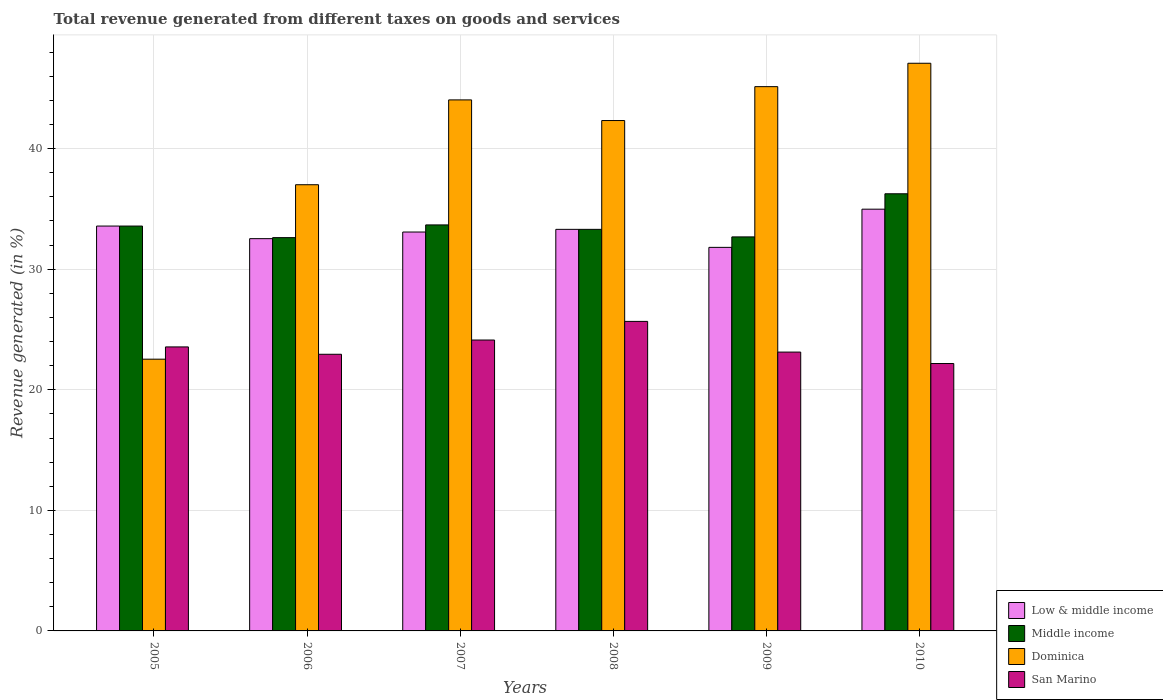How many different coloured bars are there?
Your answer should be compact. 4. Are the number of bars per tick equal to the number of legend labels?
Provide a short and direct response. Yes. What is the total revenue generated in Middle income in 2007?
Your response must be concise. 33.68. Across all years, what is the maximum total revenue generated in Dominica?
Make the answer very short. 47.08. Across all years, what is the minimum total revenue generated in Middle income?
Ensure brevity in your answer.  32.62. In which year was the total revenue generated in Middle income minimum?
Offer a terse response. 2006. What is the total total revenue generated in Low & middle income in the graph?
Your answer should be compact. 199.3. What is the difference between the total revenue generated in San Marino in 2006 and that in 2008?
Your response must be concise. -2.73. What is the difference between the total revenue generated in San Marino in 2008 and the total revenue generated in Dominica in 2005?
Your answer should be very brief. 3.13. What is the average total revenue generated in Dominica per year?
Your answer should be compact. 39.69. In the year 2005, what is the difference between the total revenue generated in Middle income and total revenue generated in San Marino?
Make the answer very short. 10.02. What is the ratio of the total revenue generated in San Marino in 2006 to that in 2009?
Your response must be concise. 0.99. Is the total revenue generated in Low & middle income in 2009 less than that in 2010?
Offer a very short reply. Yes. Is the difference between the total revenue generated in Middle income in 2005 and 2009 greater than the difference between the total revenue generated in San Marino in 2005 and 2009?
Provide a short and direct response. Yes. What is the difference between the highest and the second highest total revenue generated in Middle income?
Your answer should be compact. 2.58. What is the difference between the highest and the lowest total revenue generated in Middle income?
Give a very brief answer. 3.64. What does the 4th bar from the right in 2006 represents?
Make the answer very short. Low & middle income. Is it the case that in every year, the sum of the total revenue generated in Dominica and total revenue generated in Middle income is greater than the total revenue generated in San Marino?
Your answer should be very brief. Yes. How many bars are there?
Your answer should be very brief. 24. Are all the bars in the graph horizontal?
Keep it short and to the point. No. What is the difference between two consecutive major ticks on the Y-axis?
Offer a very short reply. 10. Does the graph contain any zero values?
Offer a very short reply. No. Where does the legend appear in the graph?
Keep it short and to the point. Bottom right. How are the legend labels stacked?
Ensure brevity in your answer.  Vertical. What is the title of the graph?
Keep it short and to the point. Total revenue generated from different taxes on goods and services. Does "Oman" appear as one of the legend labels in the graph?
Give a very brief answer. No. What is the label or title of the X-axis?
Offer a terse response. Years. What is the label or title of the Y-axis?
Provide a succinct answer. Revenue generated (in %). What is the Revenue generated (in %) of Low & middle income in 2005?
Make the answer very short. 33.58. What is the Revenue generated (in %) of Middle income in 2005?
Give a very brief answer. 33.58. What is the Revenue generated (in %) in Dominica in 2005?
Ensure brevity in your answer.  22.54. What is the Revenue generated (in %) in San Marino in 2005?
Your answer should be very brief. 23.56. What is the Revenue generated (in %) of Low & middle income in 2006?
Offer a very short reply. 32.54. What is the Revenue generated (in %) in Middle income in 2006?
Your answer should be very brief. 32.62. What is the Revenue generated (in %) of Dominica in 2006?
Your answer should be compact. 37.01. What is the Revenue generated (in %) of San Marino in 2006?
Ensure brevity in your answer.  22.95. What is the Revenue generated (in %) of Low & middle income in 2007?
Make the answer very short. 33.08. What is the Revenue generated (in %) of Middle income in 2007?
Offer a terse response. 33.68. What is the Revenue generated (in %) in Dominica in 2007?
Offer a terse response. 44.04. What is the Revenue generated (in %) in San Marino in 2007?
Give a very brief answer. 24.13. What is the Revenue generated (in %) of Low & middle income in 2008?
Keep it short and to the point. 33.31. What is the Revenue generated (in %) of Middle income in 2008?
Your answer should be very brief. 33.31. What is the Revenue generated (in %) of Dominica in 2008?
Make the answer very short. 42.33. What is the Revenue generated (in %) of San Marino in 2008?
Keep it short and to the point. 25.67. What is the Revenue generated (in %) in Low & middle income in 2009?
Your answer should be very brief. 31.81. What is the Revenue generated (in %) in Middle income in 2009?
Make the answer very short. 32.68. What is the Revenue generated (in %) of Dominica in 2009?
Provide a short and direct response. 45.14. What is the Revenue generated (in %) of San Marino in 2009?
Make the answer very short. 23.13. What is the Revenue generated (in %) in Low & middle income in 2010?
Provide a succinct answer. 34.98. What is the Revenue generated (in %) of Middle income in 2010?
Ensure brevity in your answer.  36.26. What is the Revenue generated (in %) of Dominica in 2010?
Give a very brief answer. 47.08. What is the Revenue generated (in %) of San Marino in 2010?
Your response must be concise. 22.18. Across all years, what is the maximum Revenue generated (in %) in Low & middle income?
Offer a very short reply. 34.98. Across all years, what is the maximum Revenue generated (in %) in Middle income?
Offer a terse response. 36.26. Across all years, what is the maximum Revenue generated (in %) of Dominica?
Make the answer very short. 47.08. Across all years, what is the maximum Revenue generated (in %) of San Marino?
Provide a succinct answer. 25.67. Across all years, what is the minimum Revenue generated (in %) of Low & middle income?
Offer a very short reply. 31.81. Across all years, what is the minimum Revenue generated (in %) of Middle income?
Ensure brevity in your answer.  32.62. Across all years, what is the minimum Revenue generated (in %) of Dominica?
Your response must be concise. 22.54. Across all years, what is the minimum Revenue generated (in %) in San Marino?
Offer a terse response. 22.18. What is the total Revenue generated (in %) in Low & middle income in the graph?
Keep it short and to the point. 199.3. What is the total Revenue generated (in %) in Middle income in the graph?
Keep it short and to the point. 202.12. What is the total Revenue generated (in %) in Dominica in the graph?
Ensure brevity in your answer.  238.15. What is the total Revenue generated (in %) of San Marino in the graph?
Provide a succinct answer. 141.61. What is the difference between the Revenue generated (in %) in Low & middle income in 2005 and that in 2006?
Provide a succinct answer. 1.04. What is the difference between the Revenue generated (in %) of Middle income in 2005 and that in 2006?
Offer a very short reply. 0.96. What is the difference between the Revenue generated (in %) of Dominica in 2005 and that in 2006?
Keep it short and to the point. -14.47. What is the difference between the Revenue generated (in %) in San Marino in 2005 and that in 2006?
Offer a very short reply. 0.61. What is the difference between the Revenue generated (in %) of Low & middle income in 2005 and that in 2007?
Ensure brevity in your answer.  0.5. What is the difference between the Revenue generated (in %) of Middle income in 2005 and that in 2007?
Keep it short and to the point. -0.1. What is the difference between the Revenue generated (in %) of Dominica in 2005 and that in 2007?
Offer a terse response. -21.51. What is the difference between the Revenue generated (in %) in San Marino in 2005 and that in 2007?
Your response must be concise. -0.57. What is the difference between the Revenue generated (in %) of Low & middle income in 2005 and that in 2008?
Your response must be concise. 0.27. What is the difference between the Revenue generated (in %) in Middle income in 2005 and that in 2008?
Ensure brevity in your answer.  0.27. What is the difference between the Revenue generated (in %) in Dominica in 2005 and that in 2008?
Make the answer very short. -19.79. What is the difference between the Revenue generated (in %) of San Marino in 2005 and that in 2008?
Give a very brief answer. -2.12. What is the difference between the Revenue generated (in %) in Low & middle income in 2005 and that in 2009?
Provide a short and direct response. 1.77. What is the difference between the Revenue generated (in %) of Middle income in 2005 and that in 2009?
Keep it short and to the point. 0.9. What is the difference between the Revenue generated (in %) in Dominica in 2005 and that in 2009?
Provide a short and direct response. -22.6. What is the difference between the Revenue generated (in %) in San Marino in 2005 and that in 2009?
Your answer should be compact. 0.43. What is the difference between the Revenue generated (in %) in Low & middle income in 2005 and that in 2010?
Give a very brief answer. -1.4. What is the difference between the Revenue generated (in %) in Middle income in 2005 and that in 2010?
Give a very brief answer. -2.68. What is the difference between the Revenue generated (in %) of Dominica in 2005 and that in 2010?
Offer a terse response. -24.54. What is the difference between the Revenue generated (in %) in San Marino in 2005 and that in 2010?
Provide a succinct answer. 1.38. What is the difference between the Revenue generated (in %) of Low & middle income in 2006 and that in 2007?
Keep it short and to the point. -0.55. What is the difference between the Revenue generated (in %) of Middle income in 2006 and that in 2007?
Provide a short and direct response. -1.06. What is the difference between the Revenue generated (in %) of Dominica in 2006 and that in 2007?
Give a very brief answer. -7.04. What is the difference between the Revenue generated (in %) of San Marino in 2006 and that in 2007?
Offer a terse response. -1.18. What is the difference between the Revenue generated (in %) in Low & middle income in 2006 and that in 2008?
Ensure brevity in your answer.  -0.77. What is the difference between the Revenue generated (in %) in Middle income in 2006 and that in 2008?
Provide a short and direct response. -0.69. What is the difference between the Revenue generated (in %) of Dominica in 2006 and that in 2008?
Provide a short and direct response. -5.32. What is the difference between the Revenue generated (in %) of San Marino in 2006 and that in 2008?
Your answer should be compact. -2.73. What is the difference between the Revenue generated (in %) of Low & middle income in 2006 and that in 2009?
Your answer should be very brief. 0.72. What is the difference between the Revenue generated (in %) of Middle income in 2006 and that in 2009?
Ensure brevity in your answer.  -0.06. What is the difference between the Revenue generated (in %) in Dominica in 2006 and that in 2009?
Provide a succinct answer. -8.14. What is the difference between the Revenue generated (in %) of San Marino in 2006 and that in 2009?
Your answer should be compact. -0.18. What is the difference between the Revenue generated (in %) in Low & middle income in 2006 and that in 2010?
Give a very brief answer. -2.44. What is the difference between the Revenue generated (in %) in Middle income in 2006 and that in 2010?
Ensure brevity in your answer.  -3.64. What is the difference between the Revenue generated (in %) of Dominica in 2006 and that in 2010?
Make the answer very short. -10.07. What is the difference between the Revenue generated (in %) of San Marino in 2006 and that in 2010?
Ensure brevity in your answer.  0.77. What is the difference between the Revenue generated (in %) of Low & middle income in 2007 and that in 2008?
Ensure brevity in your answer.  -0.22. What is the difference between the Revenue generated (in %) in Middle income in 2007 and that in 2008?
Your answer should be very brief. 0.37. What is the difference between the Revenue generated (in %) in Dominica in 2007 and that in 2008?
Provide a short and direct response. 1.71. What is the difference between the Revenue generated (in %) in San Marino in 2007 and that in 2008?
Your answer should be compact. -1.55. What is the difference between the Revenue generated (in %) in Low & middle income in 2007 and that in 2009?
Make the answer very short. 1.27. What is the difference between the Revenue generated (in %) of Dominica in 2007 and that in 2009?
Provide a succinct answer. -1.1. What is the difference between the Revenue generated (in %) of Low & middle income in 2007 and that in 2010?
Your answer should be compact. -1.89. What is the difference between the Revenue generated (in %) of Middle income in 2007 and that in 2010?
Your answer should be compact. -2.58. What is the difference between the Revenue generated (in %) of Dominica in 2007 and that in 2010?
Offer a terse response. -3.04. What is the difference between the Revenue generated (in %) in San Marino in 2007 and that in 2010?
Provide a short and direct response. 1.95. What is the difference between the Revenue generated (in %) in Low & middle income in 2008 and that in 2009?
Provide a succinct answer. 1.49. What is the difference between the Revenue generated (in %) in Middle income in 2008 and that in 2009?
Offer a terse response. 0.63. What is the difference between the Revenue generated (in %) in Dominica in 2008 and that in 2009?
Keep it short and to the point. -2.81. What is the difference between the Revenue generated (in %) in San Marino in 2008 and that in 2009?
Give a very brief answer. 2.55. What is the difference between the Revenue generated (in %) in Low & middle income in 2008 and that in 2010?
Give a very brief answer. -1.67. What is the difference between the Revenue generated (in %) of Middle income in 2008 and that in 2010?
Provide a short and direct response. -2.95. What is the difference between the Revenue generated (in %) in Dominica in 2008 and that in 2010?
Make the answer very short. -4.75. What is the difference between the Revenue generated (in %) in San Marino in 2008 and that in 2010?
Make the answer very short. 3.49. What is the difference between the Revenue generated (in %) in Low & middle income in 2009 and that in 2010?
Offer a terse response. -3.17. What is the difference between the Revenue generated (in %) of Middle income in 2009 and that in 2010?
Provide a succinct answer. -3.58. What is the difference between the Revenue generated (in %) of Dominica in 2009 and that in 2010?
Give a very brief answer. -1.94. What is the difference between the Revenue generated (in %) of San Marino in 2009 and that in 2010?
Provide a succinct answer. 0.95. What is the difference between the Revenue generated (in %) of Low & middle income in 2005 and the Revenue generated (in %) of Middle income in 2006?
Your response must be concise. 0.96. What is the difference between the Revenue generated (in %) in Low & middle income in 2005 and the Revenue generated (in %) in Dominica in 2006?
Provide a short and direct response. -3.43. What is the difference between the Revenue generated (in %) of Low & middle income in 2005 and the Revenue generated (in %) of San Marino in 2006?
Offer a very short reply. 10.63. What is the difference between the Revenue generated (in %) in Middle income in 2005 and the Revenue generated (in %) in Dominica in 2006?
Offer a terse response. -3.43. What is the difference between the Revenue generated (in %) of Middle income in 2005 and the Revenue generated (in %) of San Marino in 2006?
Ensure brevity in your answer.  10.63. What is the difference between the Revenue generated (in %) of Dominica in 2005 and the Revenue generated (in %) of San Marino in 2006?
Offer a very short reply. -0.41. What is the difference between the Revenue generated (in %) of Low & middle income in 2005 and the Revenue generated (in %) of Middle income in 2007?
Give a very brief answer. -0.1. What is the difference between the Revenue generated (in %) in Low & middle income in 2005 and the Revenue generated (in %) in Dominica in 2007?
Offer a very short reply. -10.46. What is the difference between the Revenue generated (in %) of Low & middle income in 2005 and the Revenue generated (in %) of San Marino in 2007?
Give a very brief answer. 9.45. What is the difference between the Revenue generated (in %) of Middle income in 2005 and the Revenue generated (in %) of Dominica in 2007?
Ensure brevity in your answer.  -10.46. What is the difference between the Revenue generated (in %) of Middle income in 2005 and the Revenue generated (in %) of San Marino in 2007?
Provide a short and direct response. 9.45. What is the difference between the Revenue generated (in %) in Dominica in 2005 and the Revenue generated (in %) in San Marino in 2007?
Ensure brevity in your answer.  -1.59. What is the difference between the Revenue generated (in %) in Low & middle income in 2005 and the Revenue generated (in %) in Middle income in 2008?
Your response must be concise. 0.27. What is the difference between the Revenue generated (in %) in Low & middle income in 2005 and the Revenue generated (in %) in Dominica in 2008?
Your response must be concise. -8.75. What is the difference between the Revenue generated (in %) of Low & middle income in 2005 and the Revenue generated (in %) of San Marino in 2008?
Your response must be concise. 7.91. What is the difference between the Revenue generated (in %) of Middle income in 2005 and the Revenue generated (in %) of Dominica in 2008?
Offer a terse response. -8.75. What is the difference between the Revenue generated (in %) of Middle income in 2005 and the Revenue generated (in %) of San Marino in 2008?
Your answer should be compact. 7.91. What is the difference between the Revenue generated (in %) in Dominica in 2005 and the Revenue generated (in %) in San Marino in 2008?
Your answer should be compact. -3.13. What is the difference between the Revenue generated (in %) in Low & middle income in 2005 and the Revenue generated (in %) in Middle income in 2009?
Keep it short and to the point. 0.9. What is the difference between the Revenue generated (in %) in Low & middle income in 2005 and the Revenue generated (in %) in Dominica in 2009?
Make the answer very short. -11.56. What is the difference between the Revenue generated (in %) of Low & middle income in 2005 and the Revenue generated (in %) of San Marino in 2009?
Provide a short and direct response. 10.45. What is the difference between the Revenue generated (in %) of Middle income in 2005 and the Revenue generated (in %) of Dominica in 2009?
Your response must be concise. -11.56. What is the difference between the Revenue generated (in %) of Middle income in 2005 and the Revenue generated (in %) of San Marino in 2009?
Keep it short and to the point. 10.45. What is the difference between the Revenue generated (in %) in Dominica in 2005 and the Revenue generated (in %) in San Marino in 2009?
Your answer should be compact. -0.59. What is the difference between the Revenue generated (in %) of Low & middle income in 2005 and the Revenue generated (in %) of Middle income in 2010?
Provide a succinct answer. -2.68. What is the difference between the Revenue generated (in %) in Low & middle income in 2005 and the Revenue generated (in %) in Dominica in 2010?
Offer a very short reply. -13.5. What is the difference between the Revenue generated (in %) in Low & middle income in 2005 and the Revenue generated (in %) in San Marino in 2010?
Provide a succinct answer. 11.4. What is the difference between the Revenue generated (in %) in Middle income in 2005 and the Revenue generated (in %) in Dominica in 2010?
Give a very brief answer. -13.5. What is the difference between the Revenue generated (in %) of Middle income in 2005 and the Revenue generated (in %) of San Marino in 2010?
Offer a very short reply. 11.4. What is the difference between the Revenue generated (in %) of Dominica in 2005 and the Revenue generated (in %) of San Marino in 2010?
Offer a very short reply. 0.36. What is the difference between the Revenue generated (in %) in Low & middle income in 2006 and the Revenue generated (in %) in Middle income in 2007?
Keep it short and to the point. -1.14. What is the difference between the Revenue generated (in %) in Low & middle income in 2006 and the Revenue generated (in %) in Dominica in 2007?
Provide a short and direct response. -11.51. What is the difference between the Revenue generated (in %) in Low & middle income in 2006 and the Revenue generated (in %) in San Marino in 2007?
Your answer should be compact. 8.41. What is the difference between the Revenue generated (in %) of Middle income in 2006 and the Revenue generated (in %) of Dominica in 2007?
Offer a terse response. -11.42. What is the difference between the Revenue generated (in %) in Middle income in 2006 and the Revenue generated (in %) in San Marino in 2007?
Give a very brief answer. 8.49. What is the difference between the Revenue generated (in %) of Dominica in 2006 and the Revenue generated (in %) of San Marino in 2007?
Offer a very short reply. 12.88. What is the difference between the Revenue generated (in %) of Low & middle income in 2006 and the Revenue generated (in %) of Middle income in 2008?
Your answer should be compact. -0.77. What is the difference between the Revenue generated (in %) of Low & middle income in 2006 and the Revenue generated (in %) of Dominica in 2008?
Your answer should be very brief. -9.8. What is the difference between the Revenue generated (in %) of Low & middle income in 2006 and the Revenue generated (in %) of San Marino in 2008?
Offer a very short reply. 6.86. What is the difference between the Revenue generated (in %) in Middle income in 2006 and the Revenue generated (in %) in Dominica in 2008?
Your answer should be very brief. -9.71. What is the difference between the Revenue generated (in %) of Middle income in 2006 and the Revenue generated (in %) of San Marino in 2008?
Ensure brevity in your answer.  6.95. What is the difference between the Revenue generated (in %) of Dominica in 2006 and the Revenue generated (in %) of San Marino in 2008?
Ensure brevity in your answer.  11.34. What is the difference between the Revenue generated (in %) of Low & middle income in 2006 and the Revenue generated (in %) of Middle income in 2009?
Make the answer very short. -0.15. What is the difference between the Revenue generated (in %) of Low & middle income in 2006 and the Revenue generated (in %) of Dominica in 2009?
Offer a terse response. -12.61. What is the difference between the Revenue generated (in %) in Low & middle income in 2006 and the Revenue generated (in %) in San Marino in 2009?
Make the answer very short. 9.41. What is the difference between the Revenue generated (in %) of Middle income in 2006 and the Revenue generated (in %) of Dominica in 2009?
Give a very brief answer. -12.52. What is the difference between the Revenue generated (in %) in Middle income in 2006 and the Revenue generated (in %) in San Marino in 2009?
Ensure brevity in your answer.  9.49. What is the difference between the Revenue generated (in %) of Dominica in 2006 and the Revenue generated (in %) of San Marino in 2009?
Make the answer very short. 13.88. What is the difference between the Revenue generated (in %) of Low & middle income in 2006 and the Revenue generated (in %) of Middle income in 2010?
Give a very brief answer. -3.72. What is the difference between the Revenue generated (in %) in Low & middle income in 2006 and the Revenue generated (in %) in Dominica in 2010?
Provide a succinct answer. -14.55. What is the difference between the Revenue generated (in %) of Low & middle income in 2006 and the Revenue generated (in %) of San Marino in 2010?
Your answer should be compact. 10.36. What is the difference between the Revenue generated (in %) of Middle income in 2006 and the Revenue generated (in %) of Dominica in 2010?
Provide a short and direct response. -14.46. What is the difference between the Revenue generated (in %) of Middle income in 2006 and the Revenue generated (in %) of San Marino in 2010?
Offer a terse response. 10.44. What is the difference between the Revenue generated (in %) in Dominica in 2006 and the Revenue generated (in %) in San Marino in 2010?
Give a very brief answer. 14.83. What is the difference between the Revenue generated (in %) of Low & middle income in 2007 and the Revenue generated (in %) of Middle income in 2008?
Offer a terse response. -0.22. What is the difference between the Revenue generated (in %) in Low & middle income in 2007 and the Revenue generated (in %) in Dominica in 2008?
Your answer should be compact. -9.25. What is the difference between the Revenue generated (in %) of Low & middle income in 2007 and the Revenue generated (in %) of San Marino in 2008?
Offer a terse response. 7.41. What is the difference between the Revenue generated (in %) in Middle income in 2007 and the Revenue generated (in %) in Dominica in 2008?
Your answer should be compact. -8.66. What is the difference between the Revenue generated (in %) of Middle income in 2007 and the Revenue generated (in %) of San Marino in 2008?
Give a very brief answer. 8. What is the difference between the Revenue generated (in %) in Dominica in 2007 and the Revenue generated (in %) in San Marino in 2008?
Keep it short and to the point. 18.37. What is the difference between the Revenue generated (in %) of Low & middle income in 2007 and the Revenue generated (in %) of Middle income in 2009?
Ensure brevity in your answer.  0.4. What is the difference between the Revenue generated (in %) of Low & middle income in 2007 and the Revenue generated (in %) of Dominica in 2009?
Your response must be concise. -12.06. What is the difference between the Revenue generated (in %) of Low & middle income in 2007 and the Revenue generated (in %) of San Marino in 2009?
Your answer should be very brief. 9.96. What is the difference between the Revenue generated (in %) of Middle income in 2007 and the Revenue generated (in %) of Dominica in 2009?
Ensure brevity in your answer.  -11.47. What is the difference between the Revenue generated (in %) in Middle income in 2007 and the Revenue generated (in %) in San Marino in 2009?
Offer a very short reply. 10.55. What is the difference between the Revenue generated (in %) in Dominica in 2007 and the Revenue generated (in %) in San Marino in 2009?
Give a very brief answer. 20.92. What is the difference between the Revenue generated (in %) in Low & middle income in 2007 and the Revenue generated (in %) in Middle income in 2010?
Offer a terse response. -3.17. What is the difference between the Revenue generated (in %) of Low & middle income in 2007 and the Revenue generated (in %) of Dominica in 2010?
Keep it short and to the point. -14. What is the difference between the Revenue generated (in %) of Low & middle income in 2007 and the Revenue generated (in %) of San Marino in 2010?
Offer a very short reply. 10.91. What is the difference between the Revenue generated (in %) in Middle income in 2007 and the Revenue generated (in %) in Dominica in 2010?
Provide a succinct answer. -13.41. What is the difference between the Revenue generated (in %) of Middle income in 2007 and the Revenue generated (in %) of San Marino in 2010?
Your answer should be compact. 11.5. What is the difference between the Revenue generated (in %) in Dominica in 2007 and the Revenue generated (in %) in San Marino in 2010?
Offer a terse response. 21.87. What is the difference between the Revenue generated (in %) of Low & middle income in 2008 and the Revenue generated (in %) of Middle income in 2009?
Offer a very short reply. 0.63. What is the difference between the Revenue generated (in %) in Low & middle income in 2008 and the Revenue generated (in %) in Dominica in 2009?
Offer a very short reply. -11.84. What is the difference between the Revenue generated (in %) of Low & middle income in 2008 and the Revenue generated (in %) of San Marino in 2009?
Keep it short and to the point. 10.18. What is the difference between the Revenue generated (in %) of Middle income in 2008 and the Revenue generated (in %) of Dominica in 2009?
Your answer should be very brief. -11.84. What is the difference between the Revenue generated (in %) of Middle income in 2008 and the Revenue generated (in %) of San Marino in 2009?
Ensure brevity in your answer.  10.18. What is the difference between the Revenue generated (in %) of Dominica in 2008 and the Revenue generated (in %) of San Marino in 2009?
Your response must be concise. 19.2. What is the difference between the Revenue generated (in %) in Low & middle income in 2008 and the Revenue generated (in %) in Middle income in 2010?
Offer a very short reply. -2.95. What is the difference between the Revenue generated (in %) of Low & middle income in 2008 and the Revenue generated (in %) of Dominica in 2010?
Provide a short and direct response. -13.78. What is the difference between the Revenue generated (in %) of Low & middle income in 2008 and the Revenue generated (in %) of San Marino in 2010?
Make the answer very short. 11.13. What is the difference between the Revenue generated (in %) of Middle income in 2008 and the Revenue generated (in %) of Dominica in 2010?
Your answer should be compact. -13.78. What is the difference between the Revenue generated (in %) of Middle income in 2008 and the Revenue generated (in %) of San Marino in 2010?
Make the answer very short. 11.13. What is the difference between the Revenue generated (in %) of Dominica in 2008 and the Revenue generated (in %) of San Marino in 2010?
Ensure brevity in your answer.  20.15. What is the difference between the Revenue generated (in %) of Low & middle income in 2009 and the Revenue generated (in %) of Middle income in 2010?
Your answer should be very brief. -4.45. What is the difference between the Revenue generated (in %) in Low & middle income in 2009 and the Revenue generated (in %) in Dominica in 2010?
Ensure brevity in your answer.  -15.27. What is the difference between the Revenue generated (in %) of Low & middle income in 2009 and the Revenue generated (in %) of San Marino in 2010?
Ensure brevity in your answer.  9.63. What is the difference between the Revenue generated (in %) in Middle income in 2009 and the Revenue generated (in %) in Dominica in 2010?
Your response must be concise. -14.4. What is the difference between the Revenue generated (in %) of Middle income in 2009 and the Revenue generated (in %) of San Marino in 2010?
Ensure brevity in your answer.  10.5. What is the difference between the Revenue generated (in %) of Dominica in 2009 and the Revenue generated (in %) of San Marino in 2010?
Give a very brief answer. 22.96. What is the average Revenue generated (in %) in Low & middle income per year?
Keep it short and to the point. 33.22. What is the average Revenue generated (in %) in Middle income per year?
Offer a terse response. 33.69. What is the average Revenue generated (in %) in Dominica per year?
Keep it short and to the point. 39.69. What is the average Revenue generated (in %) in San Marino per year?
Give a very brief answer. 23.6. In the year 2005, what is the difference between the Revenue generated (in %) in Low & middle income and Revenue generated (in %) in Dominica?
Give a very brief answer. 11.04. In the year 2005, what is the difference between the Revenue generated (in %) in Low & middle income and Revenue generated (in %) in San Marino?
Provide a succinct answer. 10.02. In the year 2005, what is the difference between the Revenue generated (in %) in Middle income and Revenue generated (in %) in Dominica?
Offer a terse response. 11.04. In the year 2005, what is the difference between the Revenue generated (in %) in Middle income and Revenue generated (in %) in San Marino?
Offer a very short reply. 10.02. In the year 2005, what is the difference between the Revenue generated (in %) in Dominica and Revenue generated (in %) in San Marino?
Keep it short and to the point. -1.02. In the year 2006, what is the difference between the Revenue generated (in %) in Low & middle income and Revenue generated (in %) in Middle income?
Offer a very short reply. -0.09. In the year 2006, what is the difference between the Revenue generated (in %) in Low & middle income and Revenue generated (in %) in Dominica?
Offer a very short reply. -4.47. In the year 2006, what is the difference between the Revenue generated (in %) in Low & middle income and Revenue generated (in %) in San Marino?
Your answer should be very brief. 9.59. In the year 2006, what is the difference between the Revenue generated (in %) in Middle income and Revenue generated (in %) in Dominica?
Keep it short and to the point. -4.39. In the year 2006, what is the difference between the Revenue generated (in %) of Middle income and Revenue generated (in %) of San Marino?
Your response must be concise. 9.67. In the year 2006, what is the difference between the Revenue generated (in %) in Dominica and Revenue generated (in %) in San Marino?
Offer a very short reply. 14.06. In the year 2007, what is the difference between the Revenue generated (in %) in Low & middle income and Revenue generated (in %) in Middle income?
Offer a very short reply. -0.59. In the year 2007, what is the difference between the Revenue generated (in %) in Low & middle income and Revenue generated (in %) in Dominica?
Offer a terse response. -10.96. In the year 2007, what is the difference between the Revenue generated (in %) of Low & middle income and Revenue generated (in %) of San Marino?
Your answer should be compact. 8.96. In the year 2007, what is the difference between the Revenue generated (in %) in Middle income and Revenue generated (in %) in Dominica?
Offer a very short reply. -10.37. In the year 2007, what is the difference between the Revenue generated (in %) in Middle income and Revenue generated (in %) in San Marino?
Offer a very short reply. 9.55. In the year 2007, what is the difference between the Revenue generated (in %) in Dominica and Revenue generated (in %) in San Marino?
Ensure brevity in your answer.  19.92. In the year 2008, what is the difference between the Revenue generated (in %) in Low & middle income and Revenue generated (in %) in Dominica?
Offer a very short reply. -9.02. In the year 2008, what is the difference between the Revenue generated (in %) of Low & middle income and Revenue generated (in %) of San Marino?
Offer a terse response. 7.63. In the year 2008, what is the difference between the Revenue generated (in %) in Middle income and Revenue generated (in %) in Dominica?
Your answer should be compact. -9.02. In the year 2008, what is the difference between the Revenue generated (in %) in Middle income and Revenue generated (in %) in San Marino?
Ensure brevity in your answer.  7.63. In the year 2008, what is the difference between the Revenue generated (in %) in Dominica and Revenue generated (in %) in San Marino?
Provide a short and direct response. 16.66. In the year 2009, what is the difference between the Revenue generated (in %) of Low & middle income and Revenue generated (in %) of Middle income?
Provide a succinct answer. -0.87. In the year 2009, what is the difference between the Revenue generated (in %) of Low & middle income and Revenue generated (in %) of Dominica?
Ensure brevity in your answer.  -13.33. In the year 2009, what is the difference between the Revenue generated (in %) of Low & middle income and Revenue generated (in %) of San Marino?
Your answer should be compact. 8.69. In the year 2009, what is the difference between the Revenue generated (in %) of Middle income and Revenue generated (in %) of Dominica?
Ensure brevity in your answer.  -12.46. In the year 2009, what is the difference between the Revenue generated (in %) in Middle income and Revenue generated (in %) in San Marino?
Your response must be concise. 9.55. In the year 2009, what is the difference between the Revenue generated (in %) in Dominica and Revenue generated (in %) in San Marino?
Your answer should be very brief. 22.02. In the year 2010, what is the difference between the Revenue generated (in %) of Low & middle income and Revenue generated (in %) of Middle income?
Your answer should be compact. -1.28. In the year 2010, what is the difference between the Revenue generated (in %) of Low & middle income and Revenue generated (in %) of Dominica?
Your answer should be compact. -12.1. In the year 2010, what is the difference between the Revenue generated (in %) of Low & middle income and Revenue generated (in %) of San Marino?
Make the answer very short. 12.8. In the year 2010, what is the difference between the Revenue generated (in %) in Middle income and Revenue generated (in %) in Dominica?
Provide a succinct answer. -10.83. In the year 2010, what is the difference between the Revenue generated (in %) in Middle income and Revenue generated (in %) in San Marino?
Ensure brevity in your answer.  14.08. In the year 2010, what is the difference between the Revenue generated (in %) of Dominica and Revenue generated (in %) of San Marino?
Give a very brief answer. 24.9. What is the ratio of the Revenue generated (in %) of Low & middle income in 2005 to that in 2006?
Provide a succinct answer. 1.03. What is the ratio of the Revenue generated (in %) of Middle income in 2005 to that in 2006?
Your response must be concise. 1.03. What is the ratio of the Revenue generated (in %) of Dominica in 2005 to that in 2006?
Provide a short and direct response. 0.61. What is the ratio of the Revenue generated (in %) in San Marino in 2005 to that in 2006?
Your response must be concise. 1.03. What is the ratio of the Revenue generated (in %) in Low & middle income in 2005 to that in 2007?
Offer a very short reply. 1.01. What is the ratio of the Revenue generated (in %) of Dominica in 2005 to that in 2007?
Offer a terse response. 0.51. What is the ratio of the Revenue generated (in %) of San Marino in 2005 to that in 2007?
Your response must be concise. 0.98. What is the ratio of the Revenue generated (in %) in Low & middle income in 2005 to that in 2008?
Provide a short and direct response. 1.01. What is the ratio of the Revenue generated (in %) in Middle income in 2005 to that in 2008?
Your response must be concise. 1.01. What is the ratio of the Revenue generated (in %) in Dominica in 2005 to that in 2008?
Make the answer very short. 0.53. What is the ratio of the Revenue generated (in %) in San Marino in 2005 to that in 2008?
Your response must be concise. 0.92. What is the ratio of the Revenue generated (in %) of Low & middle income in 2005 to that in 2009?
Give a very brief answer. 1.06. What is the ratio of the Revenue generated (in %) in Middle income in 2005 to that in 2009?
Your answer should be very brief. 1.03. What is the ratio of the Revenue generated (in %) of Dominica in 2005 to that in 2009?
Offer a very short reply. 0.5. What is the ratio of the Revenue generated (in %) in San Marino in 2005 to that in 2009?
Offer a very short reply. 1.02. What is the ratio of the Revenue generated (in %) of Middle income in 2005 to that in 2010?
Your answer should be compact. 0.93. What is the ratio of the Revenue generated (in %) in Dominica in 2005 to that in 2010?
Offer a terse response. 0.48. What is the ratio of the Revenue generated (in %) in San Marino in 2005 to that in 2010?
Your answer should be very brief. 1.06. What is the ratio of the Revenue generated (in %) of Low & middle income in 2006 to that in 2007?
Ensure brevity in your answer.  0.98. What is the ratio of the Revenue generated (in %) in Middle income in 2006 to that in 2007?
Your answer should be compact. 0.97. What is the ratio of the Revenue generated (in %) in Dominica in 2006 to that in 2007?
Give a very brief answer. 0.84. What is the ratio of the Revenue generated (in %) of San Marino in 2006 to that in 2007?
Provide a succinct answer. 0.95. What is the ratio of the Revenue generated (in %) in Low & middle income in 2006 to that in 2008?
Provide a short and direct response. 0.98. What is the ratio of the Revenue generated (in %) of Middle income in 2006 to that in 2008?
Keep it short and to the point. 0.98. What is the ratio of the Revenue generated (in %) of Dominica in 2006 to that in 2008?
Make the answer very short. 0.87. What is the ratio of the Revenue generated (in %) in San Marino in 2006 to that in 2008?
Give a very brief answer. 0.89. What is the ratio of the Revenue generated (in %) in Low & middle income in 2006 to that in 2009?
Ensure brevity in your answer.  1.02. What is the ratio of the Revenue generated (in %) in Dominica in 2006 to that in 2009?
Offer a terse response. 0.82. What is the ratio of the Revenue generated (in %) of Low & middle income in 2006 to that in 2010?
Provide a short and direct response. 0.93. What is the ratio of the Revenue generated (in %) of Middle income in 2006 to that in 2010?
Keep it short and to the point. 0.9. What is the ratio of the Revenue generated (in %) of Dominica in 2006 to that in 2010?
Provide a succinct answer. 0.79. What is the ratio of the Revenue generated (in %) of San Marino in 2006 to that in 2010?
Ensure brevity in your answer.  1.03. What is the ratio of the Revenue generated (in %) of Middle income in 2007 to that in 2008?
Your response must be concise. 1.01. What is the ratio of the Revenue generated (in %) in Dominica in 2007 to that in 2008?
Your answer should be compact. 1.04. What is the ratio of the Revenue generated (in %) in San Marino in 2007 to that in 2008?
Keep it short and to the point. 0.94. What is the ratio of the Revenue generated (in %) of Low & middle income in 2007 to that in 2009?
Give a very brief answer. 1.04. What is the ratio of the Revenue generated (in %) of Middle income in 2007 to that in 2009?
Offer a terse response. 1.03. What is the ratio of the Revenue generated (in %) in Dominica in 2007 to that in 2009?
Offer a very short reply. 0.98. What is the ratio of the Revenue generated (in %) in San Marino in 2007 to that in 2009?
Provide a short and direct response. 1.04. What is the ratio of the Revenue generated (in %) of Low & middle income in 2007 to that in 2010?
Provide a succinct answer. 0.95. What is the ratio of the Revenue generated (in %) in Middle income in 2007 to that in 2010?
Offer a very short reply. 0.93. What is the ratio of the Revenue generated (in %) of Dominica in 2007 to that in 2010?
Ensure brevity in your answer.  0.94. What is the ratio of the Revenue generated (in %) of San Marino in 2007 to that in 2010?
Your response must be concise. 1.09. What is the ratio of the Revenue generated (in %) in Low & middle income in 2008 to that in 2009?
Ensure brevity in your answer.  1.05. What is the ratio of the Revenue generated (in %) of Middle income in 2008 to that in 2009?
Offer a terse response. 1.02. What is the ratio of the Revenue generated (in %) of Dominica in 2008 to that in 2009?
Ensure brevity in your answer.  0.94. What is the ratio of the Revenue generated (in %) of San Marino in 2008 to that in 2009?
Offer a very short reply. 1.11. What is the ratio of the Revenue generated (in %) of Low & middle income in 2008 to that in 2010?
Keep it short and to the point. 0.95. What is the ratio of the Revenue generated (in %) of Middle income in 2008 to that in 2010?
Ensure brevity in your answer.  0.92. What is the ratio of the Revenue generated (in %) of Dominica in 2008 to that in 2010?
Offer a terse response. 0.9. What is the ratio of the Revenue generated (in %) of San Marino in 2008 to that in 2010?
Offer a terse response. 1.16. What is the ratio of the Revenue generated (in %) in Low & middle income in 2009 to that in 2010?
Your answer should be very brief. 0.91. What is the ratio of the Revenue generated (in %) in Middle income in 2009 to that in 2010?
Provide a short and direct response. 0.9. What is the ratio of the Revenue generated (in %) in Dominica in 2009 to that in 2010?
Your answer should be very brief. 0.96. What is the ratio of the Revenue generated (in %) of San Marino in 2009 to that in 2010?
Give a very brief answer. 1.04. What is the difference between the highest and the second highest Revenue generated (in %) in Low & middle income?
Your answer should be compact. 1.4. What is the difference between the highest and the second highest Revenue generated (in %) of Middle income?
Offer a very short reply. 2.58. What is the difference between the highest and the second highest Revenue generated (in %) of Dominica?
Ensure brevity in your answer.  1.94. What is the difference between the highest and the second highest Revenue generated (in %) in San Marino?
Keep it short and to the point. 1.55. What is the difference between the highest and the lowest Revenue generated (in %) in Low & middle income?
Offer a terse response. 3.17. What is the difference between the highest and the lowest Revenue generated (in %) in Middle income?
Your answer should be compact. 3.64. What is the difference between the highest and the lowest Revenue generated (in %) in Dominica?
Provide a succinct answer. 24.54. What is the difference between the highest and the lowest Revenue generated (in %) of San Marino?
Give a very brief answer. 3.49. 